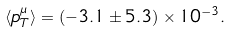<formula> <loc_0><loc_0><loc_500><loc_500>\langle p _ { T } ^ { \mu } \rangle = ( - 3 . 1 \pm 5 . 3 ) \times 1 0 ^ { - 3 } .</formula> 